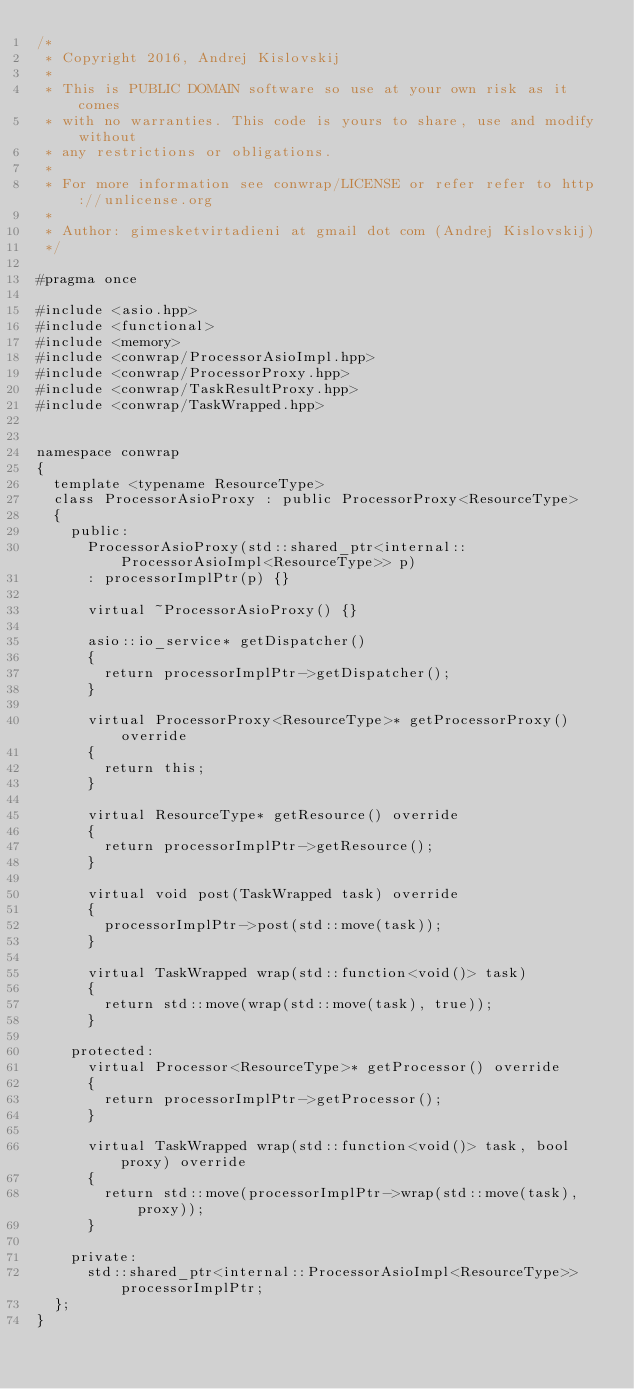Convert code to text. <code><loc_0><loc_0><loc_500><loc_500><_C++_>/*
 * Copyright 2016, Andrej Kislovskij
 *
 * This is PUBLIC DOMAIN software so use at your own risk as it comes
 * with no warranties. This code is yours to share, use and modify without
 * any restrictions or obligations.
 *
 * For more information see conwrap/LICENSE or refer refer to http://unlicense.org
 *
 * Author: gimesketvirtadieni at gmail dot com (Andrej Kislovskij)
 */

#pragma once

#include <asio.hpp>
#include <functional>
#include <memory>
#include <conwrap/ProcessorAsioImpl.hpp>
#include <conwrap/ProcessorProxy.hpp>
#include <conwrap/TaskResultProxy.hpp>
#include <conwrap/TaskWrapped.hpp>


namespace conwrap
{
	template <typename ResourceType>
	class ProcessorAsioProxy : public ProcessorProxy<ResourceType>
	{
		public:
			ProcessorAsioProxy(std::shared_ptr<internal::ProcessorAsioImpl<ResourceType>> p)
			: processorImplPtr(p) {}

			virtual ~ProcessorAsioProxy() {}

			asio::io_service* getDispatcher()
			{
				return processorImplPtr->getDispatcher();
			}

			virtual ProcessorProxy<ResourceType>* getProcessorProxy() override
			{
				return this;
			}

			virtual ResourceType* getResource() override
			{
				return processorImplPtr->getResource();
			}

			virtual void post(TaskWrapped task) override
			{
				processorImplPtr->post(std::move(task));
			}

			virtual TaskWrapped wrap(std::function<void()> task)
			{
				return std::move(wrap(std::move(task), true));
			}

		protected:
			virtual Processor<ResourceType>* getProcessor() override
			{
				return processorImplPtr->getProcessor();
			}

			virtual TaskWrapped wrap(std::function<void()> task, bool proxy) override
			{
				return std::move(processorImplPtr->wrap(std::move(task), proxy));
			}

		private:
			std::shared_ptr<internal::ProcessorAsioImpl<ResourceType>> processorImplPtr;
	};
}
</code> 